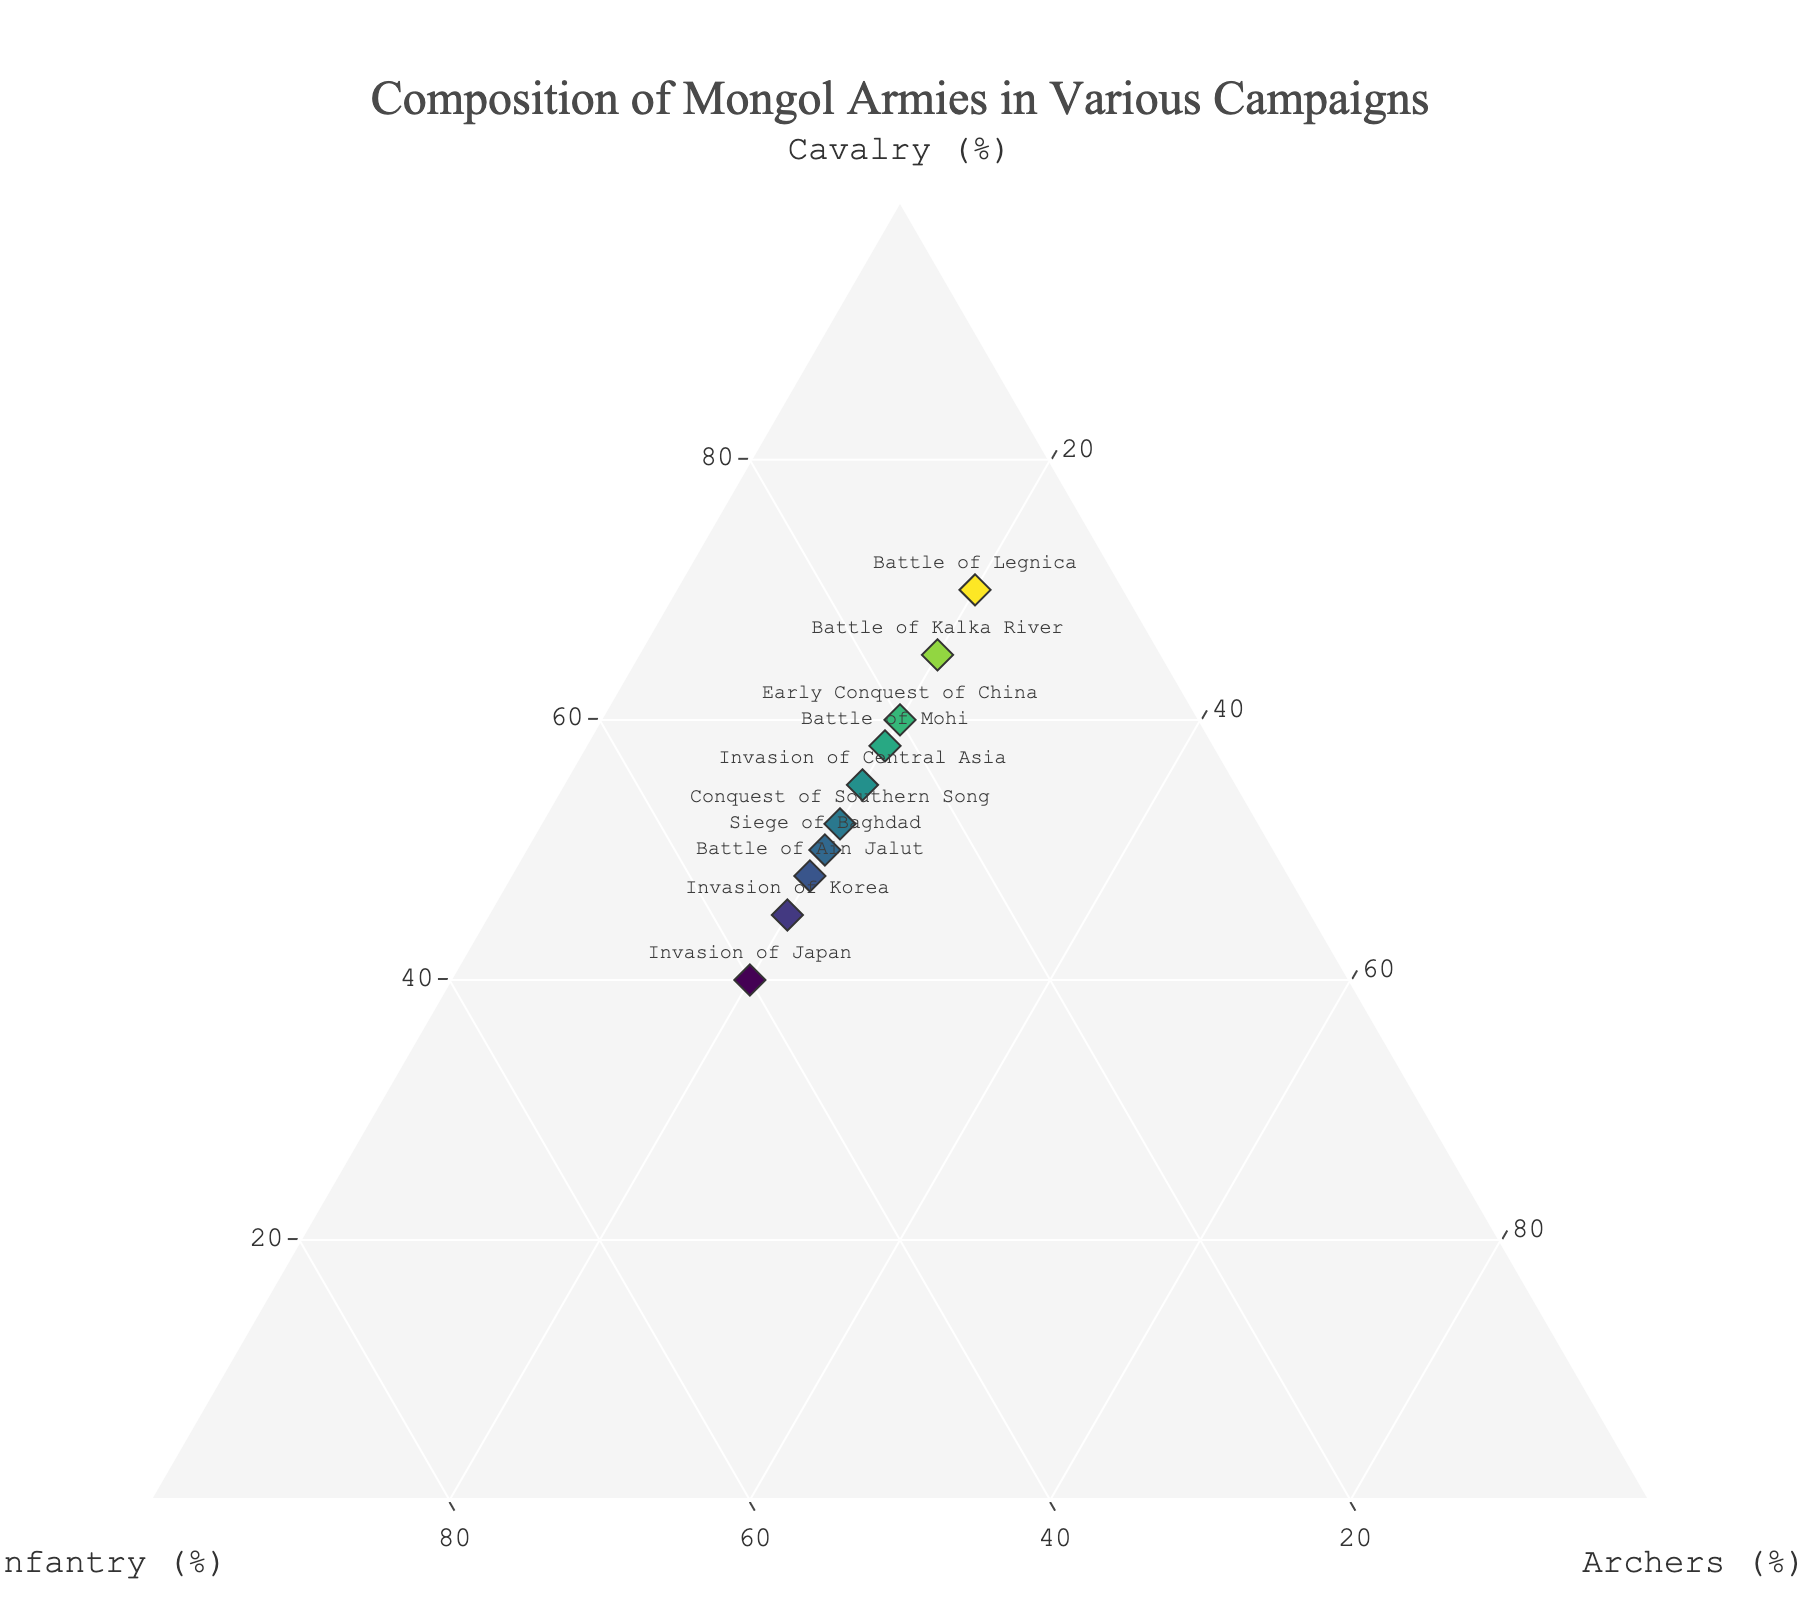what's the title of the figure? The title is typically located at the top center of the figure and reflects the overall theme and content of the plot. In this case, it summarizes the composition of the Mongol armies during different campaigns.
Answer: Composition of Mongol Armies in Various Campaigns How many data points are represented in the plot? To count the data points, observe the number of markers (usually represented as diamonds) with labels next to them or the corresponding textual data. Each data point corresponds to a specific campaign listed in the figure.
Answer: 10 During which campaign did the Mongol army have the highest proportion of infantry? Identify the data point that has the highest value on the axis labeled 'Infantry (%)'. This campaign will have the marker positioned furthest along the infantry axis.
Answer: Invasion of Japan What is the average proportion of cavalry across all campaigns? Calculate the average by summing all the cavalry percentages and dividing by the number of campaigns: (60+55+65+50+70+45+58+40+52+48) / 10.
Answer: 54.3 Which campaigns have exactly 20% Archers? Look at the 'Archers (%)' component of each data point. Identify the campaigns where this component is exactly 20%.
Answer: All campaigns listed Which campaign had the highest cavalry composition and which had the lowest? Compare the cavalry values across all campaigns to find the maximum and minimum values along with their respective campaigns.
Answer: Battle of Legnica (highest), Invasion of Japan (lowest) How does the cavalry composition in the Battle of Kalka River compare to that in the Siege of Baghdad? Locate both data points and compare their cavalry proportions directly to see which has more.
Answer: Battle of Kalka River has more cavalry What's the total proportion of infantry and archers combined for the invasion of Korea? Sum the infantry and archer proportions for the Invasion of Korea: 35% (infantry) + 20% (archers).
Answer: 55% Which campaigns fall within the range of having 50-60% cavalry? Identify campaigns with cavalry proportions within the specified range (50-60%) by examining the data points.
Answer: Early Conquest of China, Invasion of Central Asia, Siege of Baghdad, Battle of Mohi, Conquest of Southern Song, Battle of Ain Jalut Overall, do the Mongol armies have a relatively higher, lower, or equal proportion of archers compared to other units? By assessing the proportion values for archers across all points, note that all campaigns have the same proportion of archers (20%), while cavalry and infantry proportions vary more widely.
Answer: Relatively equal proportion of archers 